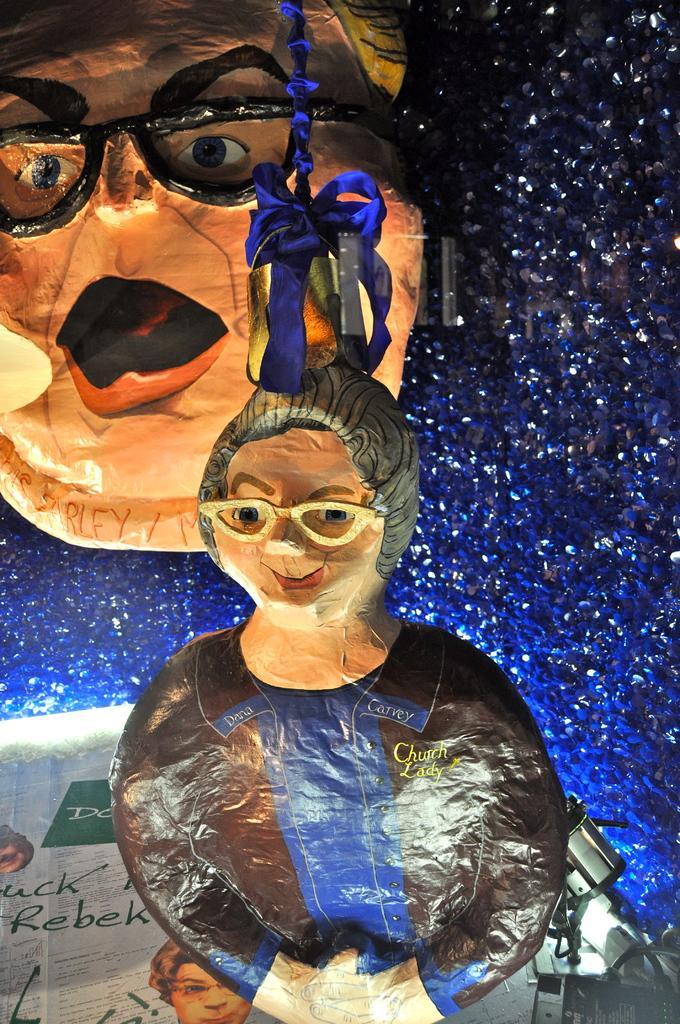Can you describe this image briefly? In this image I see a depiction of a woman and a depiction of a face and I see the blue color thing over here and I see the blue color wall and I see an electronic device over here and I see few words written over here. 